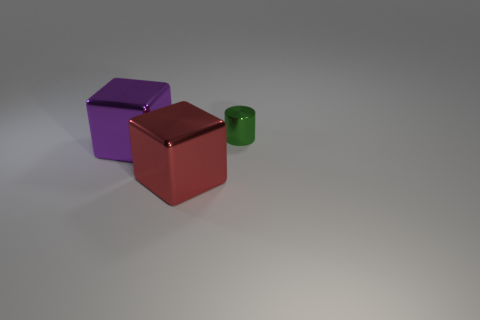Add 1 red shiny things. How many objects exist? 4 Subtract all cylinders. How many objects are left? 2 Add 1 tiny cylinders. How many tiny cylinders are left? 2 Add 2 purple things. How many purple things exist? 3 Subtract 1 purple cubes. How many objects are left? 2 Subtract all red metal things. Subtract all tiny cylinders. How many objects are left? 1 